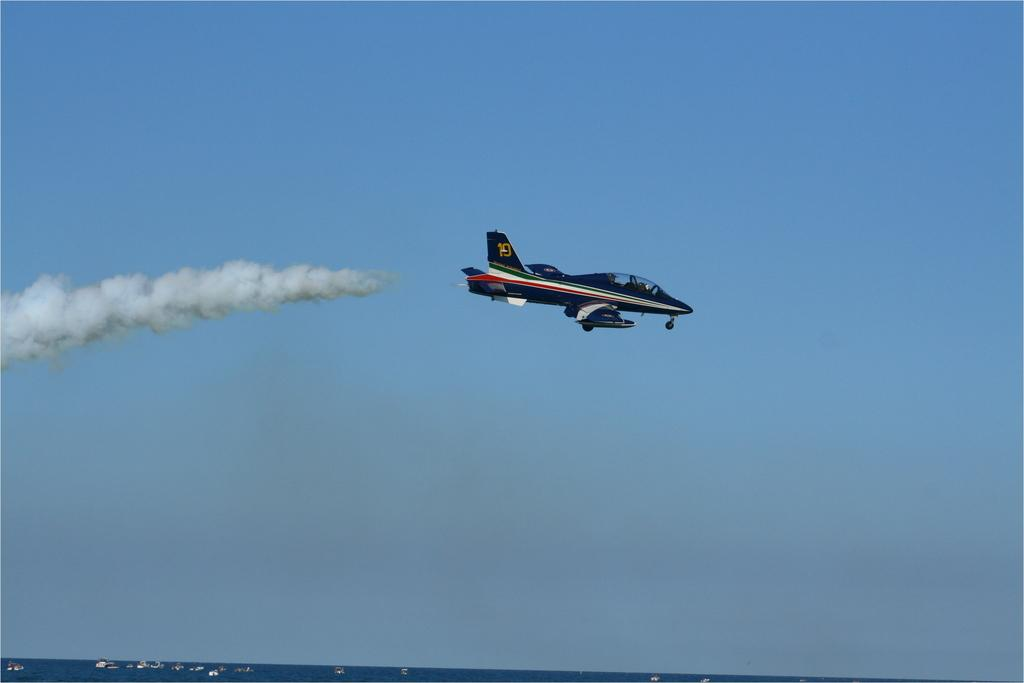<image>
Give a short and clear explanation of the subsequent image. A blue airplane with the number 10 on it flies with smoke behind it 